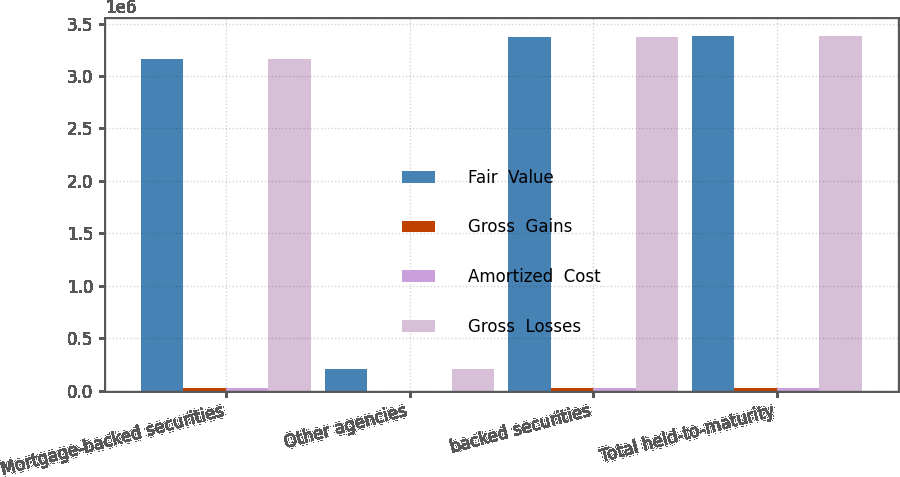Convert chart to OTSL. <chart><loc_0><loc_0><loc_500><loc_500><stacked_bar_chart><ecel><fcel>Mortgage-backed securities<fcel>Other agencies<fcel>backed securities<fcel>Total held-to-maturity<nl><fcel>Fair  Value<fcel>3.16136e+06<fcel>210563<fcel>3.37192e+06<fcel>3.3799e+06<nl><fcel>Gross  Gains<fcel>24832<fcel>1251<fcel>26083<fcel>26083<nl><fcel>Amortized  Cost<fcel>21736<fcel>1150<fcel>22886<fcel>23273<nl><fcel>Gross  Losses<fcel>3.16446e+06<fcel>210664<fcel>3.37512e+06<fcel>3.38272e+06<nl></chart> 